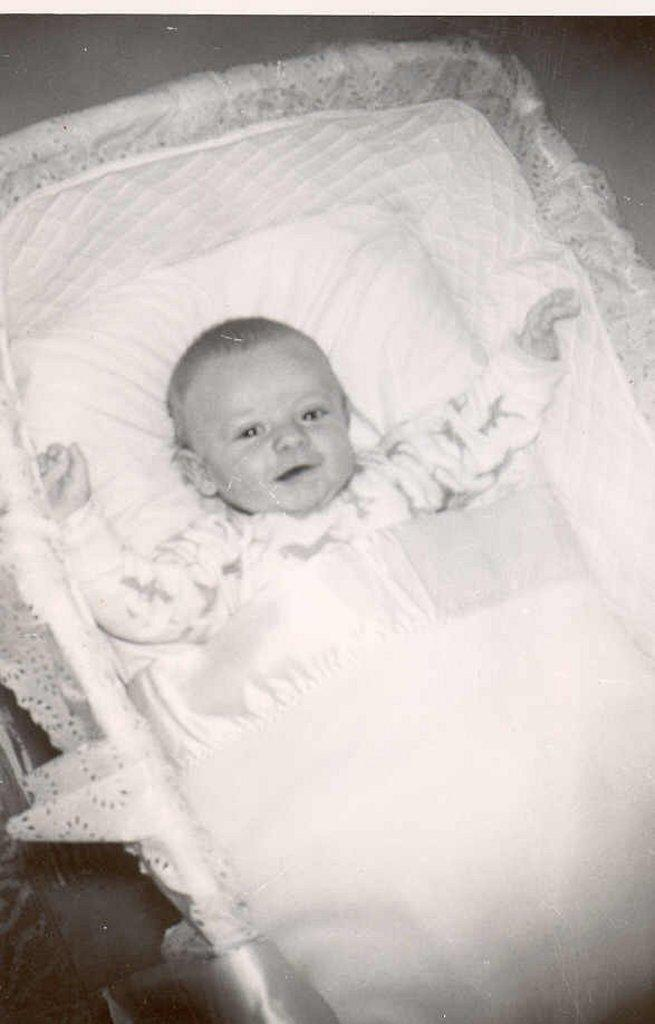What is the main subject of the image? The main subject of the image is a kid. Where is the kid located in the image? The kid is in a cradle. Can you describe the position of the cradle in the image? The cradle is in the center of the image. What type of scarf is the writer wearing in the image? There is no writer or scarf present in the image; it features a kid in a cradle. Is the doll holding a book in the image? There is no doll present in the image, so it cannot be determined if the doll is holding a book. 